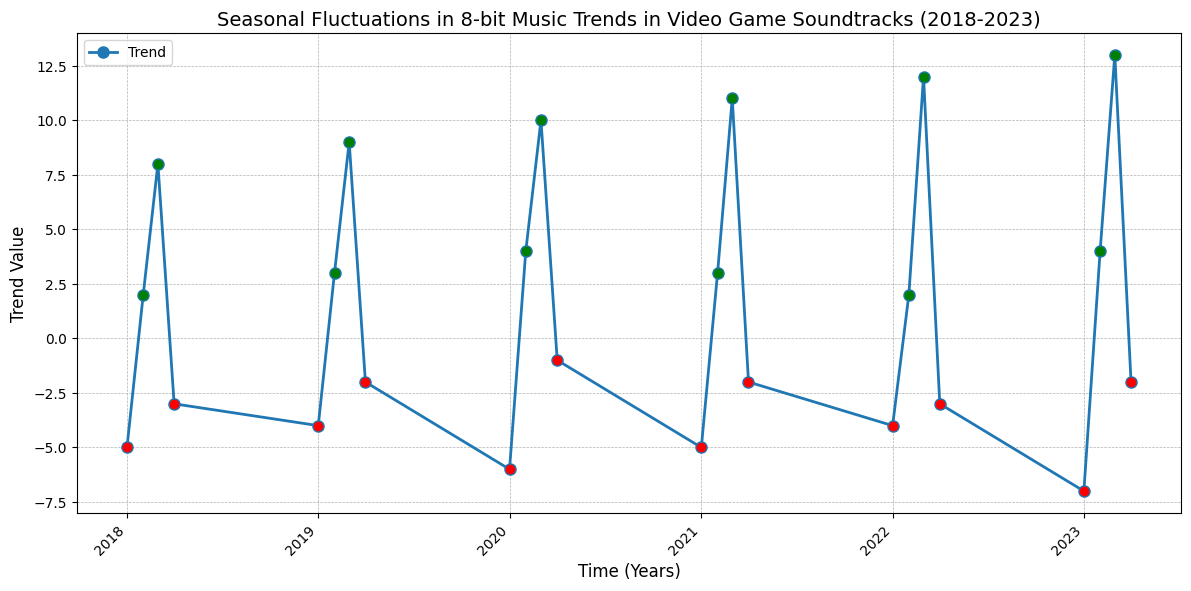What season in 2018 experienced the highest positive trend value? By observing the trend values in 2018, we see the highest positive value is 8 during Q3
Answer: Q3 Which year shows the highest trend value during Q3? By comparing the Q3 values across all years, we find 2023 has the highest trend value of 13 in Q3
Answer: 2023 What is the overall trend during Q1 of all years? Summing the Q1 trend values: (-5) + (-4) + (-6) + (-5) + (-4) + (-7) = -31. We then find the average: -31/6 = -5.17
Answer: -5.17 Compare the positive trend values in Q2 from 2018 to 2023. Which year has the highest value? The Q2 values are 2, 3, 4, 3, 2, 4. The highest is 4, which appears in 2020 and 2023
Answer: 2020 and 2023 In which season do we see the least negative trend value in 2020? Observing 2020, the negative values are -6 in Q1 and -1 in Q4. The least negative is -1 in Q4
Answer: Q4 Are there any years where one season consistently shows a negative trend? If so, which season and year? Checking each year's seasonal trends for consistent negatives: 2021 Q1 -5, Q4 -2; 2022 Q1 -4, Q4 -3; 2023 Q1 -7, Q4 -2. Q1 is consistently negative for 2021, 2022, and 2023
Answer: Q1 in 2021, 2022, and 2023 What's the average positive trend value in Q3 from 2018-2023? Q3 positive trend values are 8, 9, 10, 11, 12, 13. Summing them gives 63. The average is 63/6 = 10.5
Answer: 10.5 Compare the trend value changes from Q1 to Q2 across all years. Which year has the largest increase? Calculate the difference for each year: 2018: 2 - (-5) = 7, 2019: 3 - (-4) = 7, 2020: 4 - (-6) = 10, 2021: 3 - (-5) = 8, 2022: 2 - (-4) = 6, 2023: 4 - (-7) = 11. The largest increase is from 2023
Answer: 2023 